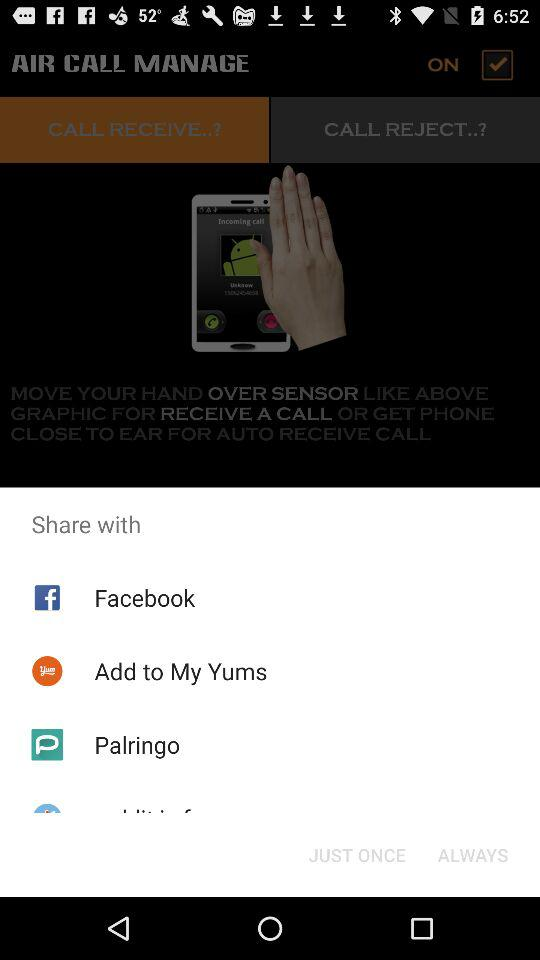What applications can we use to share? The applications you can use to share are "Facebook", "Yummly Recipes & Cooking Tools" and "Palringo". 